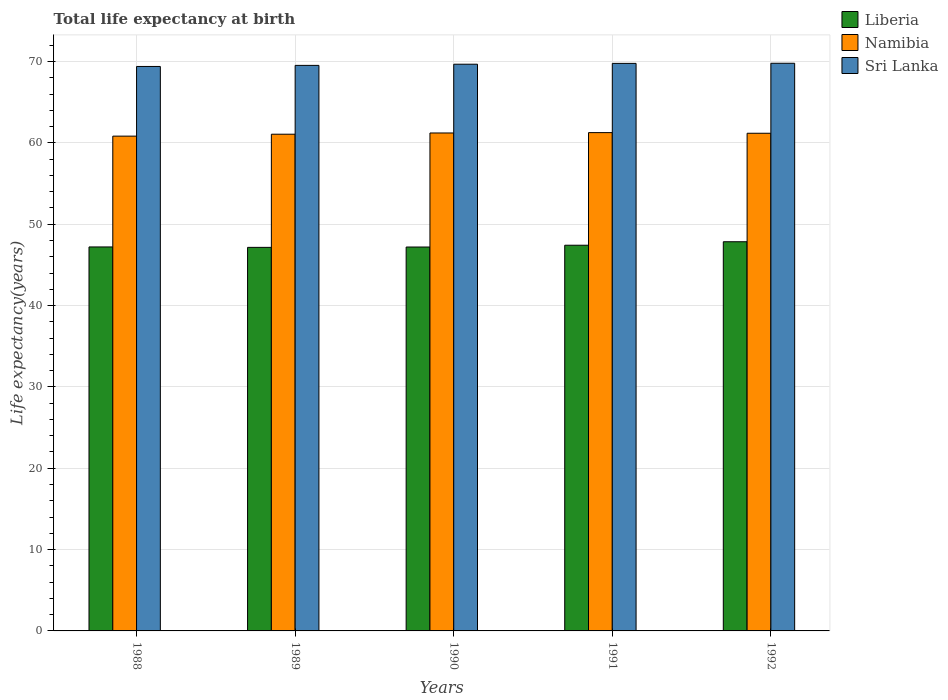How many groups of bars are there?
Keep it short and to the point. 5. Are the number of bars per tick equal to the number of legend labels?
Ensure brevity in your answer.  Yes. How many bars are there on the 3rd tick from the left?
Your answer should be very brief. 3. How many bars are there on the 2nd tick from the right?
Your answer should be compact. 3. In how many cases, is the number of bars for a given year not equal to the number of legend labels?
Make the answer very short. 0. What is the life expectancy at birth in in Sri Lanka in 1992?
Give a very brief answer. 69.8. Across all years, what is the maximum life expectancy at birth in in Liberia?
Offer a very short reply. 47.85. Across all years, what is the minimum life expectancy at birth in in Liberia?
Ensure brevity in your answer.  47.16. In which year was the life expectancy at birth in in Liberia maximum?
Your answer should be compact. 1992. What is the total life expectancy at birth in in Liberia in the graph?
Give a very brief answer. 236.85. What is the difference between the life expectancy at birth in in Namibia in 1988 and that in 1991?
Offer a terse response. -0.43. What is the difference between the life expectancy at birth in in Sri Lanka in 1992 and the life expectancy at birth in in Namibia in 1991?
Your answer should be very brief. 8.53. What is the average life expectancy at birth in in Namibia per year?
Provide a short and direct response. 61.12. In the year 1991, what is the difference between the life expectancy at birth in in Namibia and life expectancy at birth in in Sri Lanka?
Provide a succinct answer. -8.51. What is the ratio of the life expectancy at birth in in Liberia in 1988 to that in 1992?
Keep it short and to the point. 0.99. What is the difference between the highest and the second highest life expectancy at birth in in Liberia?
Your response must be concise. 0.43. What is the difference between the highest and the lowest life expectancy at birth in in Namibia?
Your answer should be compact. 0.43. In how many years, is the life expectancy at birth in in Liberia greater than the average life expectancy at birth in in Liberia taken over all years?
Provide a succinct answer. 2. What does the 1st bar from the left in 1990 represents?
Give a very brief answer. Liberia. What does the 3rd bar from the right in 1992 represents?
Provide a succinct answer. Liberia. Are all the bars in the graph horizontal?
Your answer should be compact. No. How many years are there in the graph?
Provide a short and direct response. 5. Are the values on the major ticks of Y-axis written in scientific E-notation?
Your answer should be compact. No. Does the graph contain any zero values?
Offer a terse response. No. How are the legend labels stacked?
Offer a very short reply. Vertical. What is the title of the graph?
Your response must be concise. Total life expectancy at birth. What is the label or title of the X-axis?
Give a very brief answer. Years. What is the label or title of the Y-axis?
Make the answer very short. Life expectancy(years). What is the Life expectancy(years) of Liberia in 1988?
Keep it short and to the point. 47.21. What is the Life expectancy(years) of Namibia in 1988?
Your response must be concise. 60.84. What is the Life expectancy(years) of Sri Lanka in 1988?
Offer a very short reply. 69.4. What is the Life expectancy(years) of Liberia in 1989?
Your answer should be compact. 47.16. What is the Life expectancy(years) in Namibia in 1989?
Your answer should be very brief. 61.07. What is the Life expectancy(years) of Sri Lanka in 1989?
Keep it short and to the point. 69.53. What is the Life expectancy(years) in Liberia in 1990?
Provide a short and direct response. 47.2. What is the Life expectancy(years) in Namibia in 1990?
Make the answer very short. 61.22. What is the Life expectancy(years) in Sri Lanka in 1990?
Your answer should be compact. 69.68. What is the Life expectancy(years) in Liberia in 1991?
Ensure brevity in your answer.  47.42. What is the Life expectancy(years) of Namibia in 1991?
Offer a terse response. 61.27. What is the Life expectancy(years) in Sri Lanka in 1991?
Make the answer very short. 69.78. What is the Life expectancy(years) of Liberia in 1992?
Provide a succinct answer. 47.85. What is the Life expectancy(years) of Namibia in 1992?
Your response must be concise. 61.19. What is the Life expectancy(years) in Sri Lanka in 1992?
Give a very brief answer. 69.8. Across all years, what is the maximum Life expectancy(years) of Liberia?
Provide a succinct answer. 47.85. Across all years, what is the maximum Life expectancy(years) in Namibia?
Make the answer very short. 61.27. Across all years, what is the maximum Life expectancy(years) in Sri Lanka?
Offer a terse response. 69.8. Across all years, what is the minimum Life expectancy(years) in Liberia?
Offer a very short reply. 47.16. Across all years, what is the minimum Life expectancy(years) in Namibia?
Your response must be concise. 60.84. Across all years, what is the minimum Life expectancy(years) of Sri Lanka?
Your answer should be very brief. 69.4. What is the total Life expectancy(years) in Liberia in the graph?
Offer a very short reply. 236.85. What is the total Life expectancy(years) in Namibia in the graph?
Your response must be concise. 305.59. What is the total Life expectancy(years) of Sri Lanka in the graph?
Provide a succinct answer. 348.19. What is the difference between the Life expectancy(years) in Liberia in 1988 and that in 1989?
Your response must be concise. 0.05. What is the difference between the Life expectancy(years) in Namibia in 1988 and that in 1989?
Your response must be concise. -0.24. What is the difference between the Life expectancy(years) in Sri Lanka in 1988 and that in 1989?
Ensure brevity in your answer.  -0.13. What is the difference between the Life expectancy(years) of Liberia in 1988 and that in 1990?
Ensure brevity in your answer.  0.01. What is the difference between the Life expectancy(years) of Namibia in 1988 and that in 1990?
Make the answer very short. -0.39. What is the difference between the Life expectancy(years) of Sri Lanka in 1988 and that in 1990?
Ensure brevity in your answer.  -0.28. What is the difference between the Life expectancy(years) of Liberia in 1988 and that in 1991?
Ensure brevity in your answer.  -0.21. What is the difference between the Life expectancy(years) in Namibia in 1988 and that in 1991?
Your response must be concise. -0.43. What is the difference between the Life expectancy(years) of Sri Lanka in 1988 and that in 1991?
Provide a succinct answer. -0.38. What is the difference between the Life expectancy(years) in Liberia in 1988 and that in 1992?
Your answer should be compact. -0.64. What is the difference between the Life expectancy(years) in Namibia in 1988 and that in 1992?
Give a very brief answer. -0.35. What is the difference between the Life expectancy(years) of Sri Lanka in 1988 and that in 1992?
Your answer should be very brief. -0.39. What is the difference between the Life expectancy(years) of Liberia in 1989 and that in 1990?
Provide a short and direct response. -0.04. What is the difference between the Life expectancy(years) of Namibia in 1989 and that in 1990?
Your answer should be very brief. -0.15. What is the difference between the Life expectancy(years) in Sri Lanka in 1989 and that in 1990?
Your answer should be very brief. -0.15. What is the difference between the Life expectancy(years) in Liberia in 1989 and that in 1991?
Make the answer very short. -0.26. What is the difference between the Life expectancy(years) of Namibia in 1989 and that in 1991?
Make the answer very short. -0.2. What is the difference between the Life expectancy(years) in Sri Lanka in 1989 and that in 1991?
Your answer should be very brief. -0.25. What is the difference between the Life expectancy(years) of Liberia in 1989 and that in 1992?
Give a very brief answer. -0.69. What is the difference between the Life expectancy(years) in Namibia in 1989 and that in 1992?
Offer a terse response. -0.12. What is the difference between the Life expectancy(years) of Sri Lanka in 1989 and that in 1992?
Your response must be concise. -0.26. What is the difference between the Life expectancy(years) of Liberia in 1990 and that in 1991?
Make the answer very short. -0.22. What is the difference between the Life expectancy(years) in Namibia in 1990 and that in 1991?
Provide a succinct answer. -0.04. What is the difference between the Life expectancy(years) of Sri Lanka in 1990 and that in 1991?
Your response must be concise. -0.1. What is the difference between the Life expectancy(years) of Liberia in 1990 and that in 1992?
Keep it short and to the point. -0.65. What is the difference between the Life expectancy(years) of Namibia in 1990 and that in 1992?
Offer a very short reply. 0.04. What is the difference between the Life expectancy(years) of Sri Lanka in 1990 and that in 1992?
Make the answer very short. -0.12. What is the difference between the Life expectancy(years) of Liberia in 1991 and that in 1992?
Provide a succinct answer. -0.43. What is the difference between the Life expectancy(years) in Namibia in 1991 and that in 1992?
Keep it short and to the point. 0.08. What is the difference between the Life expectancy(years) of Sri Lanka in 1991 and that in 1992?
Provide a short and direct response. -0.02. What is the difference between the Life expectancy(years) of Liberia in 1988 and the Life expectancy(years) of Namibia in 1989?
Keep it short and to the point. -13.86. What is the difference between the Life expectancy(years) of Liberia in 1988 and the Life expectancy(years) of Sri Lanka in 1989?
Your answer should be compact. -22.32. What is the difference between the Life expectancy(years) in Namibia in 1988 and the Life expectancy(years) in Sri Lanka in 1989?
Provide a succinct answer. -8.7. What is the difference between the Life expectancy(years) in Liberia in 1988 and the Life expectancy(years) in Namibia in 1990?
Provide a short and direct response. -14.01. What is the difference between the Life expectancy(years) in Liberia in 1988 and the Life expectancy(years) in Sri Lanka in 1990?
Provide a short and direct response. -22.47. What is the difference between the Life expectancy(years) of Namibia in 1988 and the Life expectancy(years) of Sri Lanka in 1990?
Your response must be concise. -8.84. What is the difference between the Life expectancy(years) in Liberia in 1988 and the Life expectancy(years) in Namibia in 1991?
Make the answer very short. -14.06. What is the difference between the Life expectancy(years) of Liberia in 1988 and the Life expectancy(years) of Sri Lanka in 1991?
Your answer should be compact. -22.57. What is the difference between the Life expectancy(years) in Namibia in 1988 and the Life expectancy(years) in Sri Lanka in 1991?
Keep it short and to the point. -8.94. What is the difference between the Life expectancy(years) in Liberia in 1988 and the Life expectancy(years) in Namibia in 1992?
Your answer should be compact. -13.98. What is the difference between the Life expectancy(years) of Liberia in 1988 and the Life expectancy(years) of Sri Lanka in 1992?
Provide a short and direct response. -22.58. What is the difference between the Life expectancy(years) in Namibia in 1988 and the Life expectancy(years) in Sri Lanka in 1992?
Your answer should be very brief. -8.96. What is the difference between the Life expectancy(years) in Liberia in 1989 and the Life expectancy(years) in Namibia in 1990?
Make the answer very short. -14.07. What is the difference between the Life expectancy(years) of Liberia in 1989 and the Life expectancy(years) of Sri Lanka in 1990?
Your answer should be very brief. -22.52. What is the difference between the Life expectancy(years) in Namibia in 1989 and the Life expectancy(years) in Sri Lanka in 1990?
Provide a succinct answer. -8.61. What is the difference between the Life expectancy(years) in Liberia in 1989 and the Life expectancy(years) in Namibia in 1991?
Offer a terse response. -14.11. What is the difference between the Life expectancy(years) of Liberia in 1989 and the Life expectancy(years) of Sri Lanka in 1991?
Your response must be concise. -22.62. What is the difference between the Life expectancy(years) of Namibia in 1989 and the Life expectancy(years) of Sri Lanka in 1991?
Provide a succinct answer. -8.71. What is the difference between the Life expectancy(years) in Liberia in 1989 and the Life expectancy(years) in Namibia in 1992?
Keep it short and to the point. -14.03. What is the difference between the Life expectancy(years) in Liberia in 1989 and the Life expectancy(years) in Sri Lanka in 1992?
Provide a short and direct response. -22.64. What is the difference between the Life expectancy(years) in Namibia in 1989 and the Life expectancy(years) in Sri Lanka in 1992?
Your response must be concise. -8.72. What is the difference between the Life expectancy(years) of Liberia in 1990 and the Life expectancy(years) of Namibia in 1991?
Your response must be concise. -14.07. What is the difference between the Life expectancy(years) of Liberia in 1990 and the Life expectancy(years) of Sri Lanka in 1991?
Provide a succinct answer. -22.58. What is the difference between the Life expectancy(years) in Namibia in 1990 and the Life expectancy(years) in Sri Lanka in 1991?
Make the answer very short. -8.56. What is the difference between the Life expectancy(years) of Liberia in 1990 and the Life expectancy(years) of Namibia in 1992?
Ensure brevity in your answer.  -13.99. What is the difference between the Life expectancy(years) in Liberia in 1990 and the Life expectancy(years) in Sri Lanka in 1992?
Provide a short and direct response. -22.59. What is the difference between the Life expectancy(years) in Namibia in 1990 and the Life expectancy(years) in Sri Lanka in 1992?
Provide a short and direct response. -8.57. What is the difference between the Life expectancy(years) of Liberia in 1991 and the Life expectancy(years) of Namibia in 1992?
Your answer should be very brief. -13.77. What is the difference between the Life expectancy(years) in Liberia in 1991 and the Life expectancy(years) in Sri Lanka in 1992?
Your answer should be very brief. -22.37. What is the difference between the Life expectancy(years) in Namibia in 1991 and the Life expectancy(years) in Sri Lanka in 1992?
Give a very brief answer. -8.53. What is the average Life expectancy(years) in Liberia per year?
Make the answer very short. 47.37. What is the average Life expectancy(years) in Namibia per year?
Offer a terse response. 61.12. What is the average Life expectancy(years) of Sri Lanka per year?
Your response must be concise. 69.64. In the year 1988, what is the difference between the Life expectancy(years) in Liberia and Life expectancy(years) in Namibia?
Keep it short and to the point. -13.63. In the year 1988, what is the difference between the Life expectancy(years) in Liberia and Life expectancy(years) in Sri Lanka?
Offer a terse response. -22.19. In the year 1988, what is the difference between the Life expectancy(years) of Namibia and Life expectancy(years) of Sri Lanka?
Give a very brief answer. -8.57. In the year 1989, what is the difference between the Life expectancy(years) in Liberia and Life expectancy(years) in Namibia?
Your answer should be compact. -13.91. In the year 1989, what is the difference between the Life expectancy(years) in Liberia and Life expectancy(years) in Sri Lanka?
Your answer should be compact. -22.37. In the year 1989, what is the difference between the Life expectancy(years) of Namibia and Life expectancy(years) of Sri Lanka?
Provide a succinct answer. -8.46. In the year 1990, what is the difference between the Life expectancy(years) in Liberia and Life expectancy(years) in Namibia?
Your response must be concise. -14.02. In the year 1990, what is the difference between the Life expectancy(years) in Liberia and Life expectancy(years) in Sri Lanka?
Keep it short and to the point. -22.48. In the year 1990, what is the difference between the Life expectancy(years) of Namibia and Life expectancy(years) of Sri Lanka?
Make the answer very short. -8.45. In the year 1991, what is the difference between the Life expectancy(years) of Liberia and Life expectancy(years) of Namibia?
Your answer should be very brief. -13.85. In the year 1991, what is the difference between the Life expectancy(years) of Liberia and Life expectancy(years) of Sri Lanka?
Your response must be concise. -22.36. In the year 1991, what is the difference between the Life expectancy(years) in Namibia and Life expectancy(years) in Sri Lanka?
Your answer should be compact. -8.51. In the year 1992, what is the difference between the Life expectancy(years) in Liberia and Life expectancy(years) in Namibia?
Ensure brevity in your answer.  -13.34. In the year 1992, what is the difference between the Life expectancy(years) of Liberia and Life expectancy(years) of Sri Lanka?
Give a very brief answer. -21.94. In the year 1992, what is the difference between the Life expectancy(years) of Namibia and Life expectancy(years) of Sri Lanka?
Your answer should be very brief. -8.61. What is the ratio of the Life expectancy(years) of Liberia in 1988 to that in 1989?
Offer a terse response. 1. What is the ratio of the Life expectancy(years) of Sri Lanka in 1988 to that in 1989?
Your response must be concise. 1. What is the ratio of the Life expectancy(years) in Liberia in 1988 to that in 1990?
Keep it short and to the point. 1. What is the ratio of the Life expectancy(years) of Namibia in 1988 to that in 1991?
Ensure brevity in your answer.  0.99. What is the ratio of the Life expectancy(years) of Liberia in 1988 to that in 1992?
Make the answer very short. 0.99. What is the ratio of the Life expectancy(years) of Sri Lanka in 1988 to that in 1992?
Ensure brevity in your answer.  0.99. What is the ratio of the Life expectancy(years) of Liberia in 1989 to that in 1990?
Offer a terse response. 1. What is the ratio of the Life expectancy(years) of Sri Lanka in 1989 to that in 1990?
Make the answer very short. 1. What is the ratio of the Life expectancy(years) of Liberia in 1989 to that in 1992?
Your answer should be compact. 0.99. What is the ratio of the Life expectancy(years) of Liberia in 1990 to that in 1991?
Offer a terse response. 1. What is the ratio of the Life expectancy(years) in Liberia in 1990 to that in 1992?
Make the answer very short. 0.99. What is the ratio of the Life expectancy(years) of Namibia in 1990 to that in 1992?
Provide a short and direct response. 1. What is the ratio of the Life expectancy(years) in Sri Lanka in 1990 to that in 1992?
Your response must be concise. 1. What is the difference between the highest and the second highest Life expectancy(years) in Liberia?
Keep it short and to the point. 0.43. What is the difference between the highest and the second highest Life expectancy(years) of Namibia?
Make the answer very short. 0.04. What is the difference between the highest and the second highest Life expectancy(years) in Sri Lanka?
Ensure brevity in your answer.  0.02. What is the difference between the highest and the lowest Life expectancy(years) of Liberia?
Your answer should be very brief. 0.69. What is the difference between the highest and the lowest Life expectancy(years) of Namibia?
Offer a very short reply. 0.43. What is the difference between the highest and the lowest Life expectancy(years) of Sri Lanka?
Offer a very short reply. 0.39. 